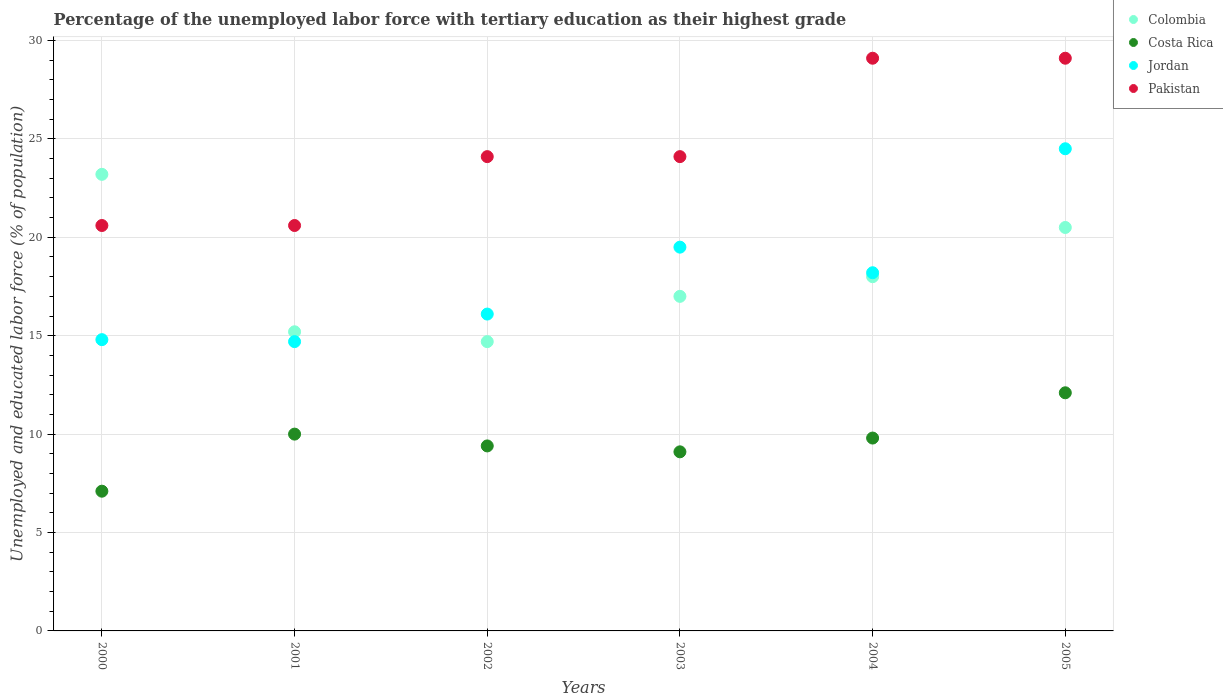Is the number of dotlines equal to the number of legend labels?
Provide a succinct answer. Yes. What is the percentage of the unemployed labor force with tertiary education in Pakistan in 2005?
Provide a short and direct response. 29.1. Across all years, what is the maximum percentage of the unemployed labor force with tertiary education in Jordan?
Provide a succinct answer. 24.5. Across all years, what is the minimum percentage of the unemployed labor force with tertiary education in Pakistan?
Ensure brevity in your answer.  20.6. In which year was the percentage of the unemployed labor force with tertiary education in Pakistan maximum?
Provide a succinct answer. 2004. In which year was the percentage of the unemployed labor force with tertiary education in Costa Rica minimum?
Keep it short and to the point. 2000. What is the total percentage of the unemployed labor force with tertiary education in Pakistan in the graph?
Your answer should be very brief. 147.6. What is the difference between the percentage of the unemployed labor force with tertiary education in Pakistan in 2001 and that in 2002?
Offer a very short reply. -3.5. What is the difference between the percentage of the unemployed labor force with tertiary education in Colombia in 2002 and the percentage of the unemployed labor force with tertiary education in Pakistan in 2003?
Offer a very short reply. -9.4. What is the average percentage of the unemployed labor force with tertiary education in Pakistan per year?
Provide a succinct answer. 24.6. In the year 2001, what is the difference between the percentage of the unemployed labor force with tertiary education in Colombia and percentage of the unemployed labor force with tertiary education in Pakistan?
Give a very brief answer. -5.4. What is the ratio of the percentage of the unemployed labor force with tertiary education in Costa Rica in 2003 to that in 2005?
Your answer should be compact. 0.75. Is the percentage of the unemployed labor force with tertiary education in Colombia in 2001 less than that in 2003?
Offer a terse response. Yes. Is the difference between the percentage of the unemployed labor force with tertiary education in Colombia in 2001 and 2004 greater than the difference between the percentage of the unemployed labor force with tertiary education in Pakistan in 2001 and 2004?
Give a very brief answer. Yes. What is the difference between the highest and the second highest percentage of the unemployed labor force with tertiary education in Jordan?
Offer a terse response. 5. What is the difference between the highest and the lowest percentage of the unemployed labor force with tertiary education in Pakistan?
Make the answer very short. 8.5. Is the sum of the percentage of the unemployed labor force with tertiary education in Costa Rica in 2000 and 2002 greater than the maximum percentage of the unemployed labor force with tertiary education in Pakistan across all years?
Your response must be concise. No. Is it the case that in every year, the sum of the percentage of the unemployed labor force with tertiary education in Jordan and percentage of the unemployed labor force with tertiary education in Costa Rica  is greater than the percentage of the unemployed labor force with tertiary education in Colombia?
Make the answer very short. No. Does the percentage of the unemployed labor force with tertiary education in Jordan monotonically increase over the years?
Provide a short and direct response. No. Is the percentage of the unemployed labor force with tertiary education in Costa Rica strictly less than the percentage of the unemployed labor force with tertiary education in Jordan over the years?
Make the answer very short. Yes. Where does the legend appear in the graph?
Your response must be concise. Top right. How many legend labels are there?
Give a very brief answer. 4. How are the legend labels stacked?
Make the answer very short. Vertical. What is the title of the graph?
Ensure brevity in your answer.  Percentage of the unemployed labor force with tertiary education as their highest grade. What is the label or title of the X-axis?
Give a very brief answer. Years. What is the label or title of the Y-axis?
Keep it short and to the point. Unemployed and educated labor force (% of population). What is the Unemployed and educated labor force (% of population) in Colombia in 2000?
Make the answer very short. 23.2. What is the Unemployed and educated labor force (% of population) in Costa Rica in 2000?
Your answer should be very brief. 7.1. What is the Unemployed and educated labor force (% of population) of Jordan in 2000?
Your response must be concise. 14.8. What is the Unemployed and educated labor force (% of population) of Pakistan in 2000?
Offer a terse response. 20.6. What is the Unemployed and educated labor force (% of population) of Colombia in 2001?
Give a very brief answer. 15.2. What is the Unemployed and educated labor force (% of population) in Costa Rica in 2001?
Your response must be concise. 10. What is the Unemployed and educated labor force (% of population) in Jordan in 2001?
Provide a succinct answer. 14.7. What is the Unemployed and educated labor force (% of population) in Pakistan in 2001?
Make the answer very short. 20.6. What is the Unemployed and educated labor force (% of population) of Colombia in 2002?
Your response must be concise. 14.7. What is the Unemployed and educated labor force (% of population) of Costa Rica in 2002?
Provide a succinct answer. 9.4. What is the Unemployed and educated labor force (% of population) of Jordan in 2002?
Your answer should be compact. 16.1. What is the Unemployed and educated labor force (% of population) of Pakistan in 2002?
Your answer should be compact. 24.1. What is the Unemployed and educated labor force (% of population) in Costa Rica in 2003?
Offer a terse response. 9.1. What is the Unemployed and educated labor force (% of population) of Jordan in 2003?
Offer a very short reply. 19.5. What is the Unemployed and educated labor force (% of population) in Pakistan in 2003?
Provide a succinct answer. 24.1. What is the Unemployed and educated labor force (% of population) in Costa Rica in 2004?
Keep it short and to the point. 9.8. What is the Unemployed and educated labor force (% of population) in Jordan in 2004?
Your response must be concise. 18.2. What is the Unemployed and educated labor force (% of population) of Pakistan in 2004?
Offer a terse response. 29.1. What is the Unemployed and educated labor force (% of population) of Colombia in 2005?
Your response must be concise. 20.5. What is the Unemployed and educated labor force (% of population) of Costa Rica in 2005?
Give a very brief answer. 12.1. What is the Unemployed and educated labor force (% of population) of Jordan in 2005?
Your response must be concise. 24.5. What is the Unemployed and educated labor force (% of population) of Pakistan in 2005?
Your answer should be very brief. 29.1. Across all years, what is the maximum Unemployed and educated labor force (% of population) of Colombia?
Keep it short and to the point. 23.2. Across all years, what is the maximum Unemployed and educated labor force (% of population) of Costa Rica?
Your response must be concise. 12.1. Across all years, what is the maximum Unemployed and educated labor force (% of population) in Jordan?
Ensure brevity in your answer.  24.5. Across all years, what is the maximum Unemployed and educated labor force (% of population) in Pakistan?
Your answer should be compact. 29.1. Across all years, what is the minimum Unemployed and educated labor force (% of population) in Colombia?
Your answer should be very brief. 14.7. Across all years, what is the minimum Unemployed and educated labor force (% of population) of Costa Rica?
Ensure brevity in your answer.  7.1. Across all years, what is the minimum Unemployed and educated labor force (% of population) in Jordan?
Your answer should be compact. 14.7. Across all years, what is the minimum Unemployed and educated labor force (% of population) in Pakistan?
Make the answer very short. 20.6. What is the total Unemployed and educated labor force (% of population) in Colombia in the graph?
Offer a terse response. 108.6. What is the total Unemployed and educated labor force (% of population) of Costa Rica in the graph?
Make the answer very short. 57.5. What is the total Unemployed and educated labor force (% of population) of Jordan in the graph?
Provide a succinct answer. 107.8. What is the total Unemployed and educated labor force (% of population) of Pakistan in the graph?
Make the answer very short. 147.6. What is the difference between the Unemployed and educated labor force (% of population) of Costa Rica in 2000 and that in 2001?
Keep it short and to the point. -2.9. What is the difference between the Unemployed and educated labor force (% of population) in Jordan in 2000 and that in 2001?
Your response must be concise. 0.1. What is the difference between the Unemployed and educated labor force (% of population) of Pakistan in 2000 and that in 2001?
Make the answer very short. 0. What is the difference between the Unemployed and educated labor force (% of population) in Pakistan in 2000 and that in 2002?
Your response must be concise. -3.5. What is the difference between the Unemployed and educated labor force (% of population) in Colombia in 2000 and that in 2003?
Your answer should be very brief. 6.2. What is the difference between the Unemployed and educated labor force (% of population) of Pakistan in 2000 and that in 2003?
Your response must be concise. -3.5. What is the difference between the Unemployed and educated labor force (% of population) in Colombia in 2000 and that in 2004?
Your answer should be very brief. 5.2. What is the difference between the Unemployed and educated labor force (% of population) of Costa Rica in 2000 and that in 2005?
Your answer should be compact. -5. What is the difference between the Unemployed and educated labor force (% of population) in Pakistan in 2000 and that in 2005?
Provide a succinct answer. -8.5. What is the difference between the Unemployed and educated labor force (% of population) in Costa Rica in 2001 and that in 2002?
Make the answer very short. 0.6. What is the difference between the Unemployed and educated labor force (% of population) of Colombia in 2001 and that in 2003?
Give a very brief answer. -1.8. What is the difference between the Unemployed and educated labor force (% of population) of Costa Rica in 2001 and that in 2003?
Provide a succinct answer. 0.9. What is the difference between the Unemployed and educated labor force (% of population) in Jordan in 2001 and that in 2003?
Provide a short and direct response. -4.8. What is the difference between the Unemployed and educated labor force (% of population) in Pakistan in 2001 and that in 2003?
Offer a very short reply. -3.5. What is the difference between the Unemployed and educated labor force (% of population) of Costa Rica in 2001 and that in 2004?
Ensure brevity in your answer.  0.2. What is the difference between the Unemployed and educated labor force (% of population) of Jordan in 2001 and that in 2004?
Offer a very short reply. -3.5. What is the difference between the Unemployed and educated labor force (% of population) in Colombia in 2001 and that in 2005?
Your response must be concise. -5.3. What is the difference between the Unemployed and educated labor force (% of population) of Costa Rica in 2002 and that in 2003?
Offer a very short reply. 0.3. What is the difference between the Unemployed and educated labor force (% of population) of Pakistan in 2002 and that in 2004?
Provide a short and direct response. -5. What is the difference between the Unemployed and educated labor force (% of population) of Jordan in 2002 and that in 2005?
Provide a short and direct response. -8.4. What is the difference between the Unemployed and educated labor force (% of population) of Pakistan in 2002 and that in 2005?
Make the answer very short. -5. What is the difference between the Unemployed and educated labor force (% of population) in Colombia in 2003 and that in 2004?
Make the answer very short. -1. What is the difference between the Unemployed and educated labor force (% of population) in Jordan in 2003 and that in 2004?
Make the answer very short. 1.3. What is the difference between the Unemployed and educated labor force (% of population) of Pakistan in 2003 and that in 2005?
Your response must be concise. -5. What is the difference between the Unemployed and educated labor force (% of population) in Jordan in 2004 and that in 2005?
Offer a very short reply. -6.3. What is the difference between the Unemployed and educated labor force (% of population) of Pakistan in 2004 and that in 2005?
Your response must be concise. 0. What is the difference between the Unemployed and educated labor force (% of population) of Colombia in 2000 and the Unemployed and educated labor force (% of population) of Costa Rica in 2001?
Give a very brief answer. 13.2. What is the difference between the Unemployed and educated labor force (% of population) in Colombia in 2000 and the Unemployed and educated labor force (% of population) in Pakistan in 2001?
Give a very brief answer. 2.6. What is the difference between the Unemployed and educated labor force (% of population) in Costa Rica in 2000 and the Unemployed and educated labor force (% of population) in Jordan in 2001?
Provide a succinct answer. -7.6. What is the difference between the Unemployed and educated labor force (% of population) of Costa Rica in 2000 and the Unemployed and educated labor force (% of population) of Pakistan in 2001?
Offer a very short reply. -13.5. What is the difference between the Unemployed and educated labor force (% of population) of Jordan in 2000 and the Unemployed and educated labor force (% of population) of Pakistan in 2001?
Your response must be concise. -5.8. What is the difference between the Unemployed and educated labor force (% of population) in Colombia in 2000 and the Unemployed and educated labor force (% of population) in Jordan in 2002?
Offer a very short reply. 7.1. What is the difference between the Unemployed and educated labor force (% of population) of Colombia in 2000 and the Unemployed and educated labor force (% of population) of Pakistan in 2002?
Offer a very short reply. -0.9. What is the difference between the Unemployed and educated labor force (% of population) of Costa Rica in 2000 and the Unemployed and educated labor force (% of population) of Jordan in 2002?
Provide a short and direct response. -9. What is the difference between the Unemployed and educated labor force (% of population) in Costa Rica in 2000 and the Unemployed and educated labor force (% of population) in Pakistan in 2002?
Give a very brief answer. -17. What is the difference between the Unemployed and educated labor force (% of population) of Colombia in 2000 and the Unemployed and educated labor force (% of population) of Costa Rica in 2003?
Your answer should be very brief. 14.1. What is the difference between the Unemployed and educated labor force (% of population) in Colombia in 2000 and the Unemployed and educated labor force (% of population) in Pakistan in 2003?
Give a very brief answer. -0.9. What is the difference between the Unemployed and educated labor force (% of population) of Costa Rica in 2000 and the Unemployed and educated labor force (% of population) of Pakistan in 2003?
Your answer should be compact. -17. What is the difference between the Unemployed and educated labor force (% of population) in Jordan in 2000 and the Unemployed and educated labor force (% of population) in Pakistan in 2003?
Provide a succinct answer. -9.3. What is the difference between the Unemployed and educated labor force (% of population) in Colombia in 2000 and the Unemployed and educated labor force (% of population) in Costa Rica in 2004?
Make the answer very short. 13.4. What is the difference between the Unemployed and educated labor force (% of population) of Colombia in 2000 and the Unemployed and educated labor force (% of population) of Pakistan in 2004?
Provide a succinct answer. -5.9. What is the difference between the Unemployed and educated labor force (% of population) in Costa Rica in 2000 and the Unemployed and educated labor force (% of population) in Pakistan in 2004?
Make the answer very short. -22. What is the difference between the Unemployed and educated labor force (% of population) in Jordan in 2000 and the Unemployed and educated labor force (% of population) in Pakistan in 2004?
Your response must be concise. -14.3. What is the difference between the Unemployed and educated labor force (% of population) of Colombia in 2000 and the Unemployed and educated labor force (% of population) of Jordan in 2005?
Give a very brief answer. -1.3. What is the difference between the Unemployed and educated labor force (% of population) of Colombia in 2000 and the Unemployed and educated labor force (% of population) of Pakistan in 2005?
Offer a very short reply. -5.9. What is the difference between the Unemployed and educated labor force (% of population) of Costa Rica in 2000 and the Unemployed and educated labor force (% of population) of Jordan in 2005?
Offer a terse response. -17.4. What is the difference between the Unemployed and educated labor force (% of population) of Costa Rica in 2000 and the Unemployed and educated labor force (% of population) of Pakistan in 2005?
Make the answer very short. -22. What is the difference between the Unemployed and educated labor force (% of population) in Jordan in 2000 and the Unemployed and educated labor force (% of population) in Pakistan in 2005?
Offer a terse response. -14.3. What is the difference between the Unemployed and educated labor force (% of population) of Colombia in 2001 and the Unemployed and educated labor force (% of population) of Pakistan in 2002?
Your answer should be very brief. -8.9. What is the difference between the Unemployed and educated labor force (% of population) in Costa Rica in 2001 and the Unemployed and educated labor force (% of population) in Jordan in 2002?
Make the answer very short. -6.1. What is the difference between the Unemployed and educated labor force (% of population) in Costa Rica in 2001 and the Unemployed and educated labor force (% of population) in Pakistan in 2002?
Your answer should be very brief. -14.1. What is the difference between the Unemployed and educated labor force (% of population) of Jordan in 2001 and the Unemployed and educated labor force (% of population) of Pakistan in 2002?
Keep it short and to the point. -9.4. What is the difference between the Unemployed and educated labor force (% of population) of Colombia in 2001 and the Unemployed and educated labor force (% of population) of Costa Rica in 2003?
Your answer should be very brief. 6.1. What is the difference between the Unemployed and educated labor force (% of population) of Colombia in 2001 and the Unemployed and educated labor force (% of population) of Pakistan in 2003?
Your response must be concise. -8.9. What is the difference between the Unemployed and educated labor force (% of population) of Costa Rica in 2001 and the Unemployed and educated labor force (% of population) of Jordan in 2003?
Your response must be concise. -9.5. What is the difference between the Unemployed and educated labor force (% of population) of Costa Rica in 2001 and the Unemployed and educated labor force (% of population) of Pakistan in 2003?
Ensure brevity in your answer.  -14.1. What is the difference between the Unemployed and educated labor force (% of population) in Jordan in 2001 and the Unemployed and educated labor force (% of population) in Pakistan in 2003?
Your answer should be compact. -9.4. What is the difference between the Unemployed and educated labor force (% of population) of Colombia in 2001 and the Unemployed and educated labor force (% of population) of Costa Rica in 2004?
Your answer should be very brief. 5.4. What is the difference between the Unemployed and educated labor force (% of population) of Colombia in 2001 and the Unemployed and educated labor force (% of population) of Jordan in 2004?
Offer a very short reply. -3. What is the difference between the Unemployed and educated labor force (% of population) in Colombia in 2001 and the Unemployed and educated labor force (% of population) in Pakistan in 2004?
Keep it short and to the point. -13.9. What is the difference between the Unemployed and educated labor force (% of population) in Costa Rica in 2001 and the Unemployed and educated labor force (% of population) in Jordan in 2004?
Keep it short and to the point. -8.2. What is the difference between the Unemployed and educated labor force (% of population) of Costa Rica in 2001 and the Unemployed and educated labor force (% of population) of Pakistan in 2004?
Your answer should be very brief. -19.1. What is the difference between the Unemployed and educated labor force (% of population) of Jordan in 2001 and the Unemployed and educated labor force (% of population) of Pakistan in 2004?
Ensure brevity in your answer.  -14.4. What is the difference between the Unemployed and educated labor force (% of population) in Colombia in 2001 and the Unemployed and educated labor force (% of population) in Pakistan in 2005?
Your response must be concise. -13.9. What is the difference between the Unemployed and educated labor force (% of population) in Costa Rica in 2001 and the Unemployed and educated labor force (% of population) in Jordan in 2005?
Make the answer very short. -14.5. What is the difference between the Unemployed and educated labor force (% of population) of Costa Rica in 2001 and the Unemployed and educated labor force (% of population) of Pakistan in 2005?
Ensure brevity in your answer.  -19.1. What is the difference between the Unemployed and educated labor force (% of population) of Jordan in 2001 and the Unemployed and educated labor force (% of population) of Pakistan in 2005?
Your response must be concise. -14.4. What is the difference between the Unemployed and educated labor force (% of population) of Colombia in 2002 and the Unemployed and educated labor force (% of population) of Jordan in 2003?
Offer a very short reply. -4.8. What is the difference between the Unemployed and educated labor force (% of population) of Costa Rica in 2002 and the Unemployed and educated labor force (% of population) of Pakistan in 2003?
Ensure brevity in your answer.  -14.7. What is the difference between the Unemployed and educated labor force (% of population) of Jordan in 2002 and the Unemployed and educated labor force (% of population) of Pakistan in 2003?
Provide a short and direct response. -8. What is the difference between the Unemployed and educated labor force (% of population) of Colombia in 2002 and the Unemployed and educated labor force (% of population) of Costa Rica in 2004?
Offer a terse response. 4.9. What is the difference between the Unemployed and educated labor force (% of population) of Colombia in 2002 and the Unemployed and educated labor force (% of population) of Jordan in 2004?
Offer a terse response. -3.5. What is the difference between the Unemployed and educated labor force (% of population) of Colombia in 2002 and the Unemployed and educated labor force (% of population) of Pakistan in 2004?
Offer a terse response. -14.4. What is the difference between the Unemployed and educated labor force (% of population) of Costa Rica in 2002 and the Unemployed and educated labor force (% of population) of Jordan in 2004?
Keep it short and to the point. -8.8. What is the difference between the Unemployed and educated labor force (% of population) in Costa Rica in 2002 and the Unemployed and educated labor force (% of population) in Pakistan in 2004?
Keep it short and to the point. -19.7. What is the difference between the Unemployed and educated labor force (% of population) of Colombia in 2002 and the Unemployed and educated labor force (% of population) of Pakistan in 2005?
Give a very brief answer. -14.4. What is the difference between the Unemployed and educated labor force (% of population) in Costa Rica in 2002 and the Unemployed and educated labor force (% of population) in Jordan in 2005?
Keep it short and to the point. -15.1. What is the difference between the Unemployed and educated labor force (% of population) in Costa Rica in 2002 and the Unemployed and educated labor force (% of population) in Pakistan in 2005?
Your answer should be very brief. -19.7. What is the difference between the Unemployed and educated labor force (% of population) in Colombia in 2003 and the Unemployed and educated labor force (% of population) in Jordan in 2004?
Keep it short and to the point. -1.2. What is the difference between the Unemployed and educated labor force (% of population) in Costa Rica in 2003 and the Unemployed and educated labor force (% of population) in Jordan in 2004?
Keep it short and to the point. -9.1. What is the difference between the Unemployed and educated labor force (% of population) of Costa Rica in 2003 and the Unemployed and educated labor force (% of population) of Pakistan in 2004?
Your answer should be very brief. -20. What is the difference between the Unemployed and educated labor force (% of population) of Jordan in 2003 and the Unemployed and educated labor force (% of population) of Pakistan in 2004?
Your response must be concise. -9.6. What is the difference between the Unemployed and educated labor force (% of population) in Colombia in 2003 and the Unemployed and educated labor force (% of population) in Costa Rica in 2005?
Make the answer very short. 4.9. What is the difference between the Unemployed and educated labor force (% of population) in Colombia in 2003 and the Unemployed and educated labor force (% of population) in Jordan in 2005?
Give a very brief answer. -7.5. What is the difference between the Unemployed and educated labor force (% of population) of Colombia in 2003 and the Unemployed and educated labor force (% of population) of Pakistan in 2005?
Give a very brief answer. -12.1. What is the difference between the Unemployed and educated labor force (% of population) of Costa Rica in 2003 and the Unemployed and educated labor force (% of population) of Jordan in 2005?
Your answer should be compact. -15.4. What is the difference between the Unemployed and educated labor force (% of population) of Jordan in 2003 and the Unemployed and educated labor force (% of population) of Pakistan in 2005?
Your response must be concise. -9.6. What is the difference between the Unemployed and educated labor force (% of population) in Colombia in 2004 and the Unemployed and educated labor force (% of population) in Costa Rica in 2005?
Provide a succinct answer. 5.9. What is the difference between the Unemployed and educated labor force (% of population) in Costa Rica in 2004 and the Unemployed and educated labor force (% of population) in Jordan in 2005?
Make the answer very short. -14.7. What is the difference between the Unemployed and educated labor force (% of population) in Costa Rica in 2004 and the Unemployed and educated labor force (% of population) in Pakistan in 2005?
Offer a very short reply. -19.3. What is the average Unemployed and educated labor force (% of population) of Colombia per year?
Offer a terse response. 18.1. What is the average Unemployed and educated labor force (% of population) of Costa Rica per year?
Ensure brevity in your answer.  9.58. What is the average Unemployed and educated labor force (% of population) of Jordan per year?
Ensure brevity in your answer.  17.97. What is the average Unemployed and educated labor force (% of population) of Pakistan per year?
Offer a very short reply. 24.6. In the year 2000, what is the difference between the Unemployed and educated labor force (% of population) of Colombia and Unemployed and educated labor force (% of population) of Costa Rica?
Ensure brevity in your answer.  16.1. In the year 2000, what is the difference between the Unemployed and educated labor force (% of population) of Colombia and Unemployed and educated labor force (% of population) of Pakistan?
Your response must be concise. 2.6. In the year 2001, what is the difference between the Unemployed and educated labor force (% of population) in Costa Rica and Unemployed and educated labor force (% of population) in Pakistan?
Offer a very short reply. -10.6. In the year 2001, what is the difference between the Unemployed and educated labor force (% of population) of Jordan and Unemployed and educated labor force (% of population) of Pakistan?
Your response must be concise. -5.9. In the year 2002, what is the difference between the Unemployed and educated labor force (% of population) in Colombia and Unemployed and educated labor force (% of population) in Costa Rica?
Give a very brief answer. 5.3. In the year 2002, what is the difference between the Unemployed and educated labor force (% of population) of Costa Rica and Unemployed and educated labor force (% of population) of Pakistan?
Keep it short and to the point. -14.7. In the year 2003, what is the difference between the Unemployed and educated labor force (% of population) of Colombia and Unemployed and educated labor force (% of population) of Costa Rica?
Offer a very short reply. 7.9. In the year 2003, what is the difference between the Unemployed and educated labor force (% of population) in Colombia and Unemployed and educated labor force (% of population) in Jordan?
Give a very brief answer. -2.5. In the year 2003, what is the difference between the Unemployed and educated labor force (% of population) in Colombia and Unemployed and educated labor force (% of population) in Pakistan?
Your answer should be compact. -7.1. In the year 2003, what is the difference between the Unemployed and educated labor force (% of population) in Costa Rica and Unemployed and educated labor force (% of population) in Pakistan?
Your answer should be compact. -15. In the year 2004, what is the difference between the Unemployed and educated labor force (% of population) in Colombia and Unemployed and educated labor force (% of population) in Jordan?
Ensure brevity in your answer.  -0.2. In the year 2004, what is the difference between the Unemployed and educated labor force (% of population) in Colombia and Unemployed and educated labor force (% of population) in Pakistan?
Provide a short and direct response. -11.1. In the year 2004, what is the difference between the Unemployed and educated labor force (% of population) in Costa Rica and Unemployed and educated labor force (% of population) in Jordan?
Give a very brief answer. -8.4. In the year 2004, what is the difference between the Unemployed and educated labor force (% of population) in Costa Rica and Unemployed and educated labor force (% of population) in Pakistan?
Your answer should be very brief. -19.3. In the year 2005, what is the difference between the Unemployed and educated labor force (% of population) in Colombia and Unemployed and educated labor force (% of population) in Costa Rica?
Offer a very short reply. 8.4. In the year 2005, what is the difference between the Unemployed and educated labor force (% of population) of Colombia and Unemployed and educated labor force (% of population) of Jordan?
Make the answer very short. -4. What is the ratio of the Unemployed and educated labor force (% of population) of Colombia in 2000 to that in 2001?
Your answer should be compact. 1.53. What is the ratio of the Unemployed and educated labor force (% of population) in Costa Rica in 2000 to that in 2001?
Make the answer very short. 0.71. What is the ratio of the Unemployed and educated labor force (% of population) of Jordan in 2000 to that in 2001?
Provide a short and direct response. 1.01. What is the ratio of the Unemployed and educated labor force (% of population) in Colombia in 2000 to that in 2002?
Give a very brief answer. 1.58. What is the ratio of the Unemployed and educated labor force (% of population) of Costa Rica in 2000 to that in 2002?
Provide a short and direct response. 0.76. What is the ratio of the Unemployed and educated labor force (% of population) in Jordan in 2000 to that in 2002?
Your answer should be very brief. 0.92. What is the ratio of the Unemployed and educated labor force (% of population) in Pakistan in 2000 to that in 2002?
Offer a terse response. 0.85. What is the ratio of the Unemployed and educated labor force (% of population) in Colombia in 2000 to that in 2003?
Keep it short and to the point. 1.36. What is the ratio of the Unemployed and educated labor force (% of population) of Costa Rica in 2000 to that in 2003?
Your answer should be very brief. 0.78. What is the ratio of the Unemployed and educated labor force (% of population) of Jordan in 2000 to that in 2003?
Your response must be concise. 0.76. What is the ratio of the Unemployed and educated labor force (% of population) of Pakistan in 2000 to that in 2003?
Your answer should be very brief. 0.85. What is the ratio of the Unemployed and educated labor force (% of population) of Colombia in 2000 to that in 2004?
Your response must be concise. 1.29. What is the ratio of the Unemployed and educated labor force (% of population) in Costa Rica in 2000 to that in 2004?
Make the answer very short. 0.72. What is the ratio of the Unemployed and educated labor force (% of population) in Jordan in 2000 to that in 2004?
Offer a terse response. 0.81. What is the ratio of the Unemployed and educated labor force (% of population) of Pakistan in 2000 to that in 2004?
Offer a very short reply. 0.71. What is the ratio of the Unemployed and educated labor force (% of population) of Colombia in 2000 to that in 2005?
Offer a very short reply. 1.13. What is the ratio of the Unemployed and educated labor force (% of population) of Costa Rica in 2000 to that in 2005?
Your response must be concise. 0.59. What is the ratio of the Unemployed and educated labor force (% of population) of Jordan in 2000 to that in 2005?
Give a very brief answer. 0.6. What is the ratio of the Unemployed and educated labor force (% of population) in Pakistan in 2000 to that in 2005?
Provide a succinct answer. 0.71. What is the ratio of the Unemployed and educated labor force (% of population) in Colombia in 2001 to that in 2002?
Your response must be concise. 1.03. What is the ratio of the Unemployed and educated labor force (% of population) in Costa Rica in 2001 to that in 2002?
Give a very brief answer. 1.06. What is the ratio of the Unemployed and educated labor force (% of population) of Pakistan in 2001 to that in 2002?
Offer a terse response. 0.85. What is the ratio of the Unemployed and educated labor force (% of population) in Colombia in 2001 to that in 2003?
Offer a very short reply. 0.89. What is the ratio of the Unemployed and educated labor force (% of population) in Costa Rica in 2001 to that in 2003?
Offer a terse response. 1.1. What is the ratio of the Unemployed and educated labor force (% of population) in Jordan in 2001 to that in 2003?
Provide a succinct answer. 0.75. What is the ratio of the Unemployed and educated labor force (% of population) of Pakistan in 2001 to that in 2003?
Your response must be concise. 0.85. What is the ratio of the Unemployed and educated labor force (% of population) in Colombia in 2001 to that in 2004?
Provide a succinct answer. 0.84. What is the ratio of the Unemployed and educated labor force (% of population) of Costa Rica in 2001 to that in 2004?
Your response must be concise. 1.02. What is the ratio of the Unemployed and educated labor force (% of population) in Jordan in 2001 to that in 2004?
Ensure brevity in your answer.  0.81. What is the ratio of the Unemployed and educated labor force (% of population) of Pakistan in 2001 to that in 2004?
Your response must be concise. 0.71. What is the ratio of the Unemployed and educated labor force (% of population) of Colombia in 2001 to that in 2005?
Ensure brevity in your answer.  0.74. What is the ratio of the Unemployed and educated labor force (% of population) in Costa Rica in 2001 to that in 2005?
Offer a very short reply. 0.83. What is the ratio of the Unemployed and educated labor force (% of population) in Pakistan in 2001 to that in 2005?
Offer a very short reply. 0.71. What is the ratio of the Unemployed and educated labor force (% of population) in Colombia in 2002 to that in 2003?
Offer a terse response. 0.86. What is the ratio of the Unemployed and educated labor force (% of population) of Costa Rica in 2002 to that in 2003?
Ensure brevity in your answer.  1.03. What is the ratio of the Unemployed and educated labor force (% of population) in Jordan in 2002 to that in 2003?
Your response must be concise. 0.83. What is the ratio of the Unemployed and educated labor force (% of population) in Colombia in 2002 to that in 2004?
Provide a short and direct response. 0.82. What is the ratio of the Unemployed and educated labor force (% of population) in Costa Rica in 2002 to that in 2004?
Your answer should be very brief. 0.96. What is the ratio of the Unemployed and educated labor force (% of population) of Jordan in 2002 to that in 2004?
Offer a very short reply. 0.88. What is the ratio of the Unemployed and educated labor force (% of population) in Pakistan in 2002 to that in 2004?
Ensure brevity in your answer.  0.83. What is the ratio of the Unemployed and educated labor force (% of population) in Colombia in 2002 to that in 2005?
Keep it short and to the point. 0.72. What is the ratio of the Unemployed and educated labor force (% of population) of Costa Rica in 2002 to that in 2005?
Ensure brevity in your answer.  0.78. What is the ratio of the Unemployed and educated labor force (% of population) of Jordan in 2002 to that in 2005?
Make the answer very short. 0.66. What is the ratio of the Unemployed and educated labor force (% of population) of Pakistan in 2002 to that in 2005?
Provide a short and direct response. 0.83. What is the ratio of the Unemployed and educated labor force (% of population) in Colombia in 2003 to that in 2004?
Offer a very short reply. 0.94. What is the ratio of the Unemployed and educated labor force (% of population) of Costa Rica in 2003 to that in 2004?
Ensure brevity in your answer.  0.93. What is the ratio of the Unemployed and educated labor force (% of population) in Jordan in 2003 to that in 2004?
Your answer should be compact. 1.07. What is the ratio of the Unemployed and educated labor force (% of population) in Pakistan in 2003 to that in 2004?
Offer a terse response. 0.83. What is the ratio of the Unemployed and educated labor force (% of population) of Colombia in 2003 to that in 2005?
Provide a short and direct response. 0.83. What is the ratio of the Unemployed and educated labor force (% of population) of Costa Rica in 2003 to that in 2005?
Your response must be concise. 0.75. What is the ratio of the Unemployed and educated labor force (% of population) in Jordan in 2003 to that in 2005?
Offer a very short reply. 0.8. What is the ratio of the Unemployed and educated labor force (% of population) of Pakistan in 2003 to that in 2005?
Your response must be concise. 0.83. What is the ratio of the Unemployed and educated labor force (% of population) in Colombia in 2004 to that in 2005?
Your response must be concise. 0.88. What is the ratio of the Unemployed and educated labor force (% of population) of Costa Rica in 2004 to that in 2005?
Provide a succinct answer. 0.81. What is the ratio of the Unemployed and educated labor force (% of population) in Jordan in 2004 to that in 2005?
Keep it short and to the point. 0.74. What is the difference between the highest and the second highest Unemployed and educated labor force (% of population) in Costa Rica?
Provide a short and direct response. 2.1. What is the difference between the highest and the second highest Unemployed and educated labor force (% of population) of Pakistan?
Provide a succinct answer. 0. What is the difference between the highest and the lowest Unemployed and educated labor force (% of population) of Colombia?
Keep it short and to the point. 8.5. What is the difference between the highest and the lowest Unemployed and educated labor force (% of population) in Costa Rica?
Offer a very short reply. 5. What is the difference between the highest and the lowest Unemployed and educated labor force (% of population) of Jordan?
Make the answer very short. 9.8. 